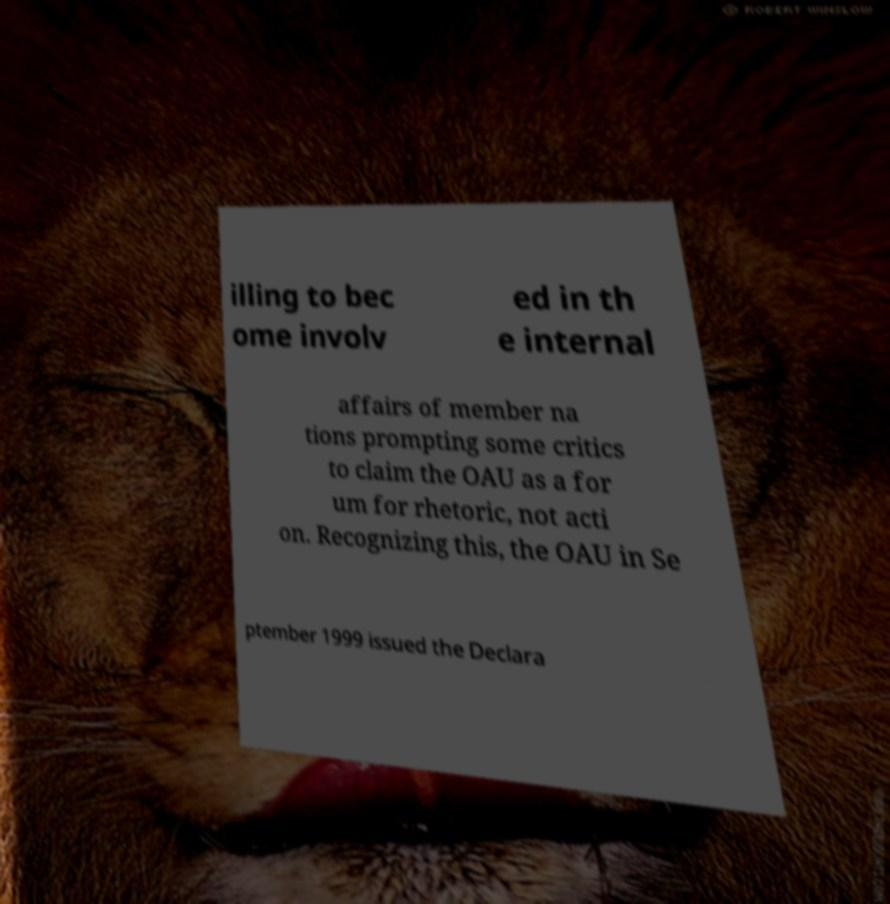What messages or text are displayed in this image? I need them in a readable, typed format. illing to bec ome involv ed in th e internal affairs of member na tions prompting some critics to claim the OAU as a for um for rhetoric, not acti on. Recognizing this, the OAU in Se ptember 1999 issued the Declara 